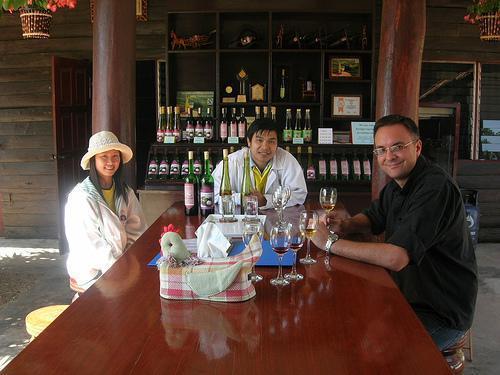How many people can be seen?
Give a very brief answer. 3. How many sandwiches are on the plate?
Give a very brief answer. 0. 